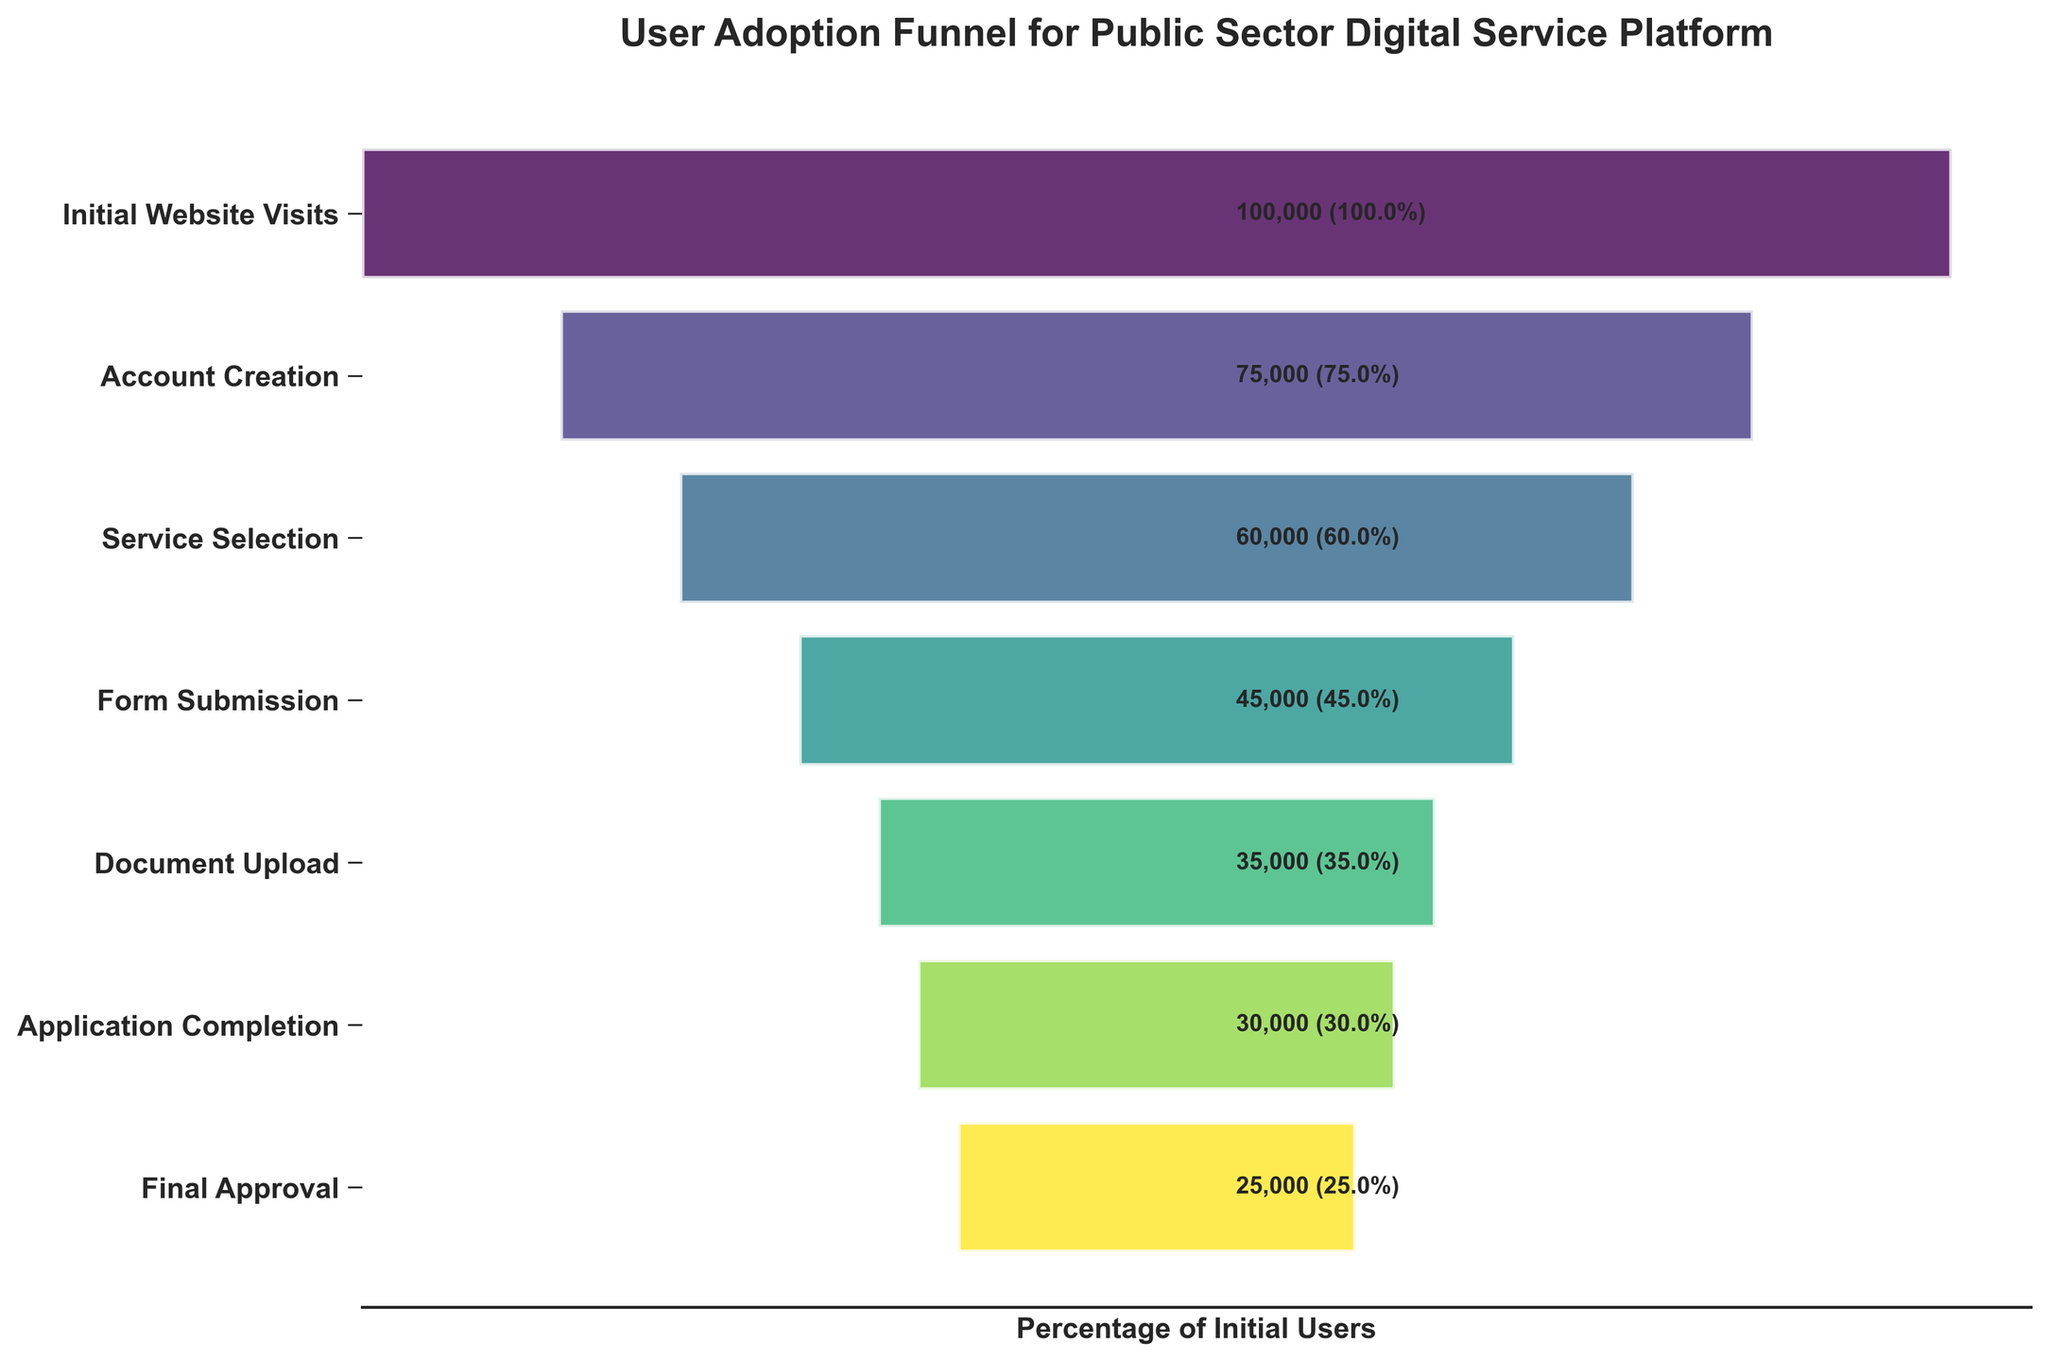What's the title of the figure? The title is usually located at the top of the figure. For this particular plot, the title is found above the funnel chart.
Answer: User Adoption Funnel for Public Sector Digital Service Platform How many stages are there in the funnel? The number of stages can be determined by counting the distinct names listed vertically on the left side of the funnel chart.
Answer: 7 What is the percentage of users that complete the 'Document Upload' stage relative to the initial number of users? To find this percentage, divide the number of users who completed the 'Document Upload' stage (35,000) by the initial number of users (100,000), then multiply by 100.
Answer: 35% Which stage experiences the most significant drop in user numbers? By examining the stages and comparing the difference in user numbers between consecutive stages, the largest drop occurs between 'Form Submission' (45,000) and 'Document Upload' (35,000). The drop is 10,000 users.
Answer: Form Submission to Document Upload What percentage of users reach the 'Final Approval' stage? To find this percentage, divide the number of users who reached the 'Final Approval' stage (25,000) by the initial number of users (100,000), then multiply by 100.
Answer: 25% How many more users complete the 'Service Selection' stage compared to the 'Form Submission' stage? Subtract the number of users who complete the 'Form Submission' stage (45,000) from those who complete the 'Service Selection' stage (60,000).
Answer: 15,000 What is the average number of users across all stages? To find the average, sum the number of users at each stage and then divide by the number of stages: (100,000 + 75,000 + 60,000 + 45,000 + 35,000 + 30,000 + 25,000) / 7.
Answer: 52,857 Which stage has the smallest number of users? By examining the user counts listed beside each stage's label, the stage with the smallest number of users is 'Final Approval' with 25,000 users.
Answer: Final Approval Is there any stage where more than 80% of the initial users remain? To check this, calculate the percentage for each stage by dividing the stage's user count by the initial number of users and multiplying by 100. The only stage where more than 80% remain is 'Account Creation' with 75,000 users, which is 75% of the initial users.
Answer: No 